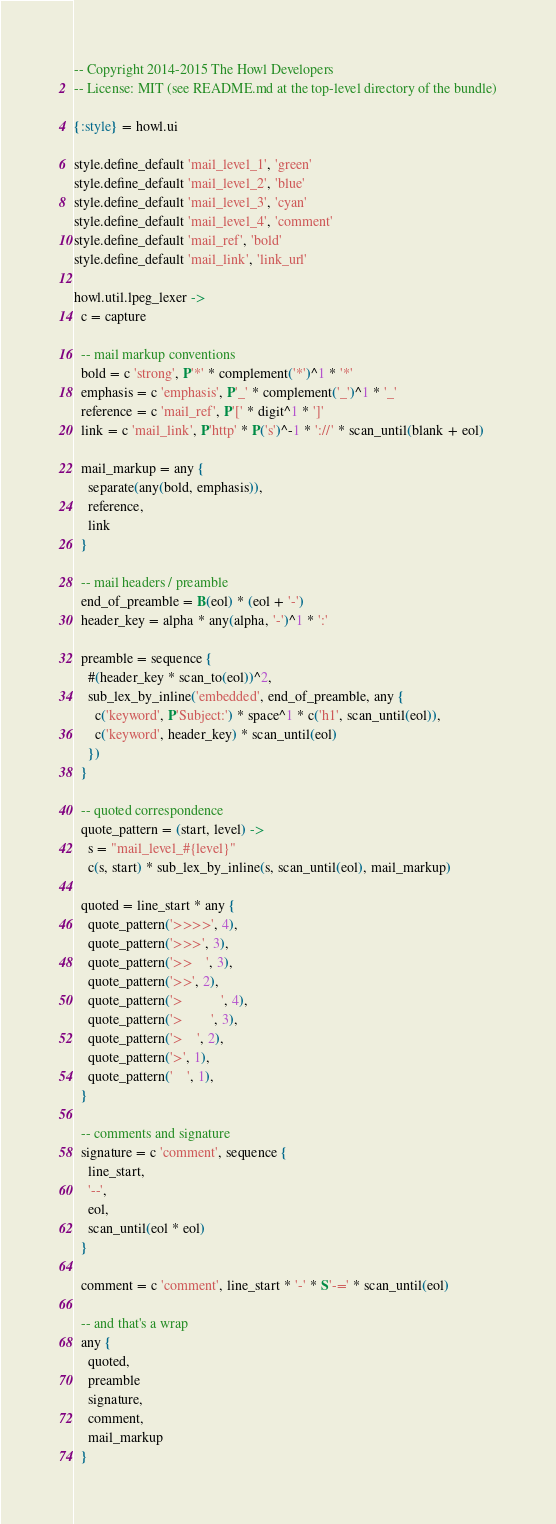Convert code to text. <code><loc_0><loc_0><loc_500><loc_500><_MoonScript_>-- Copyright 2014-2015 The Howl Developers
-- License: MIT (see README.md at the top-level directory of the bundle)

{:style} = howl.ui

style.define_default 'mail_level_1', 'green'
style.define_default 'mail_level_2', 'blue'
style.define_default 'mail_level_3', 'cyan'
style.define_default 'mail_level_4', 'comment'
style.define_default 'mail_ref', 'bold'
style.define_default 'mail_link', 'link_url'

howl.util.lpeg_lexer ->
  c = capture

  -- mail markup conventions
  bold = c 'strong', P'*' * complement('*')^1 * '*'
  emphasis = c 'emphasis', P'_' * complement('_')^1 * '_'
  reference = c 'mail_ref', P'[' * digit^1 * ']'
  link = c 'mail_link', P'http' * P('s')^-1 * '://' * scan_until(blank + eol)

  mail_markup = any {
    separate(any(bold, emphasis)),
    reference,
    link
  }

  -- mail headers / preamble
  end_of_preamble = B(eol) * (eol + '-')
  header_key = alpha * any(alpha, '-')^1 * ':'

  preamble = sequence {
    #(header_key * scan_to(eol))^2,
    sub_lex_by_inline('embedded', end_of_preamble, any {
      c('keyword', P'Subject:') * space^1 * c('h1', scan_until(eol)),
      c('keyword', header_key) * scan_until(eol)
    })
  }

  -- quoted correspondence
  quote_pattern = (start, level) ->
    s = "mail_level_#{level}"
    c(s, start) * sub_lex_by_inline(s, scan_until(eol), mail_markup)

  quoted = line_start * any {
    quote_pattern('>>>>', 4),
    quote_pattern('>>>', 3),
    quote_pattern('>>    ', 3),
    quote_pattern('>>', 2),
    quote_pattern('>           ', 4),
    quote_pattern('>        ', 3),
    quote_pattern('>    ', 2),
    quote_pattern('>', 1),
    quote_pattern('    ', 1),
  }

  -- comments and signature
  signature = c 'comment', sequence {
    line_start,
    '--',
    eol,
    scan_until(eol * eol)
  }

  comment = c 'comment', line_start * '-' * S'-=' * scan_until(eol)

  -- and that's a wrap
  any {
    quoted,
    preamble
    signature,
    comment,
    mail_markup
  }
</code> 